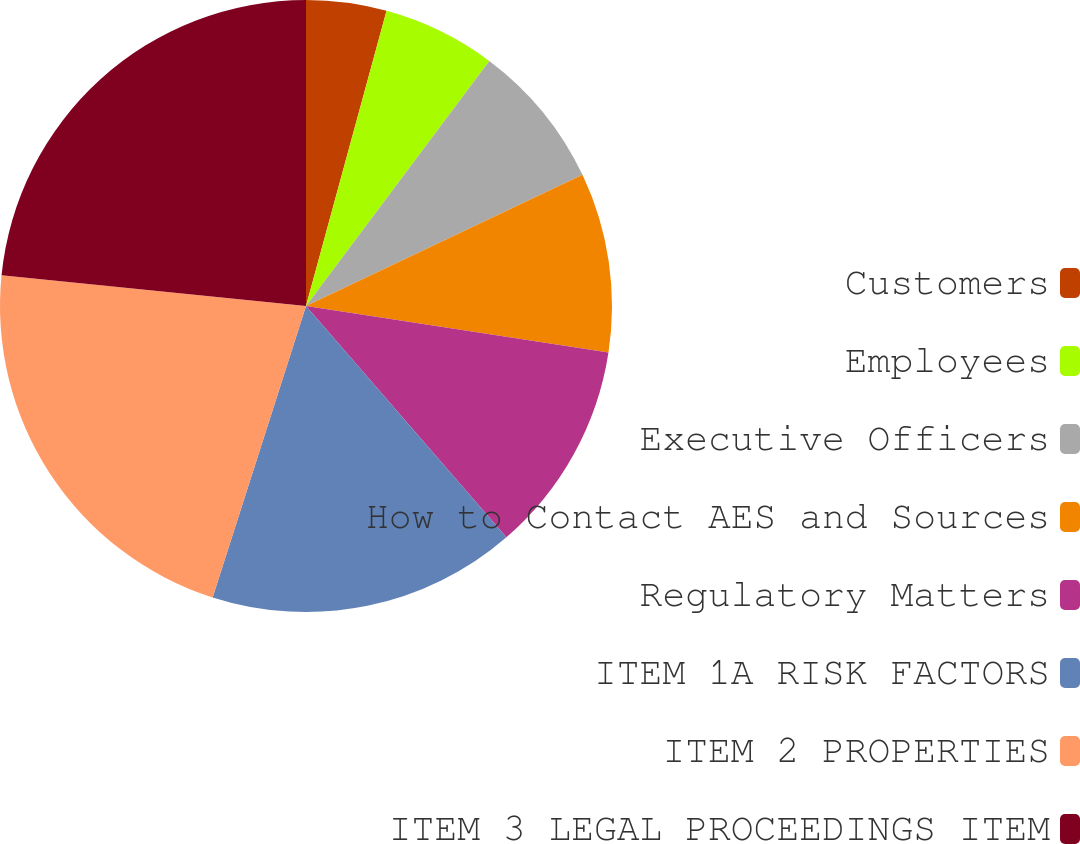Convert chart to OTSL. <chart><loc_0><loc_0><loc_500><loc_500><pie_chart><fcel>Customers<fcel>Employees<fcel>Executive Officers<fcel>How to Contact AES and Sources<fcel>Regulatory Matters<fcel>ITEM 1A RISK FACTORS<fcel>ITEM 2 PROPERTIES<fcel>ITEM 3 LEGAL PROCEEDINGS ITEM<nl><fcel>4.24%<fcel>5.98%<fcel>7.73%<fcel>9.47%<fcel>11.21%<fcel>16.3%<fcel>21.66%<fcel>23.4%<nl></chart> 